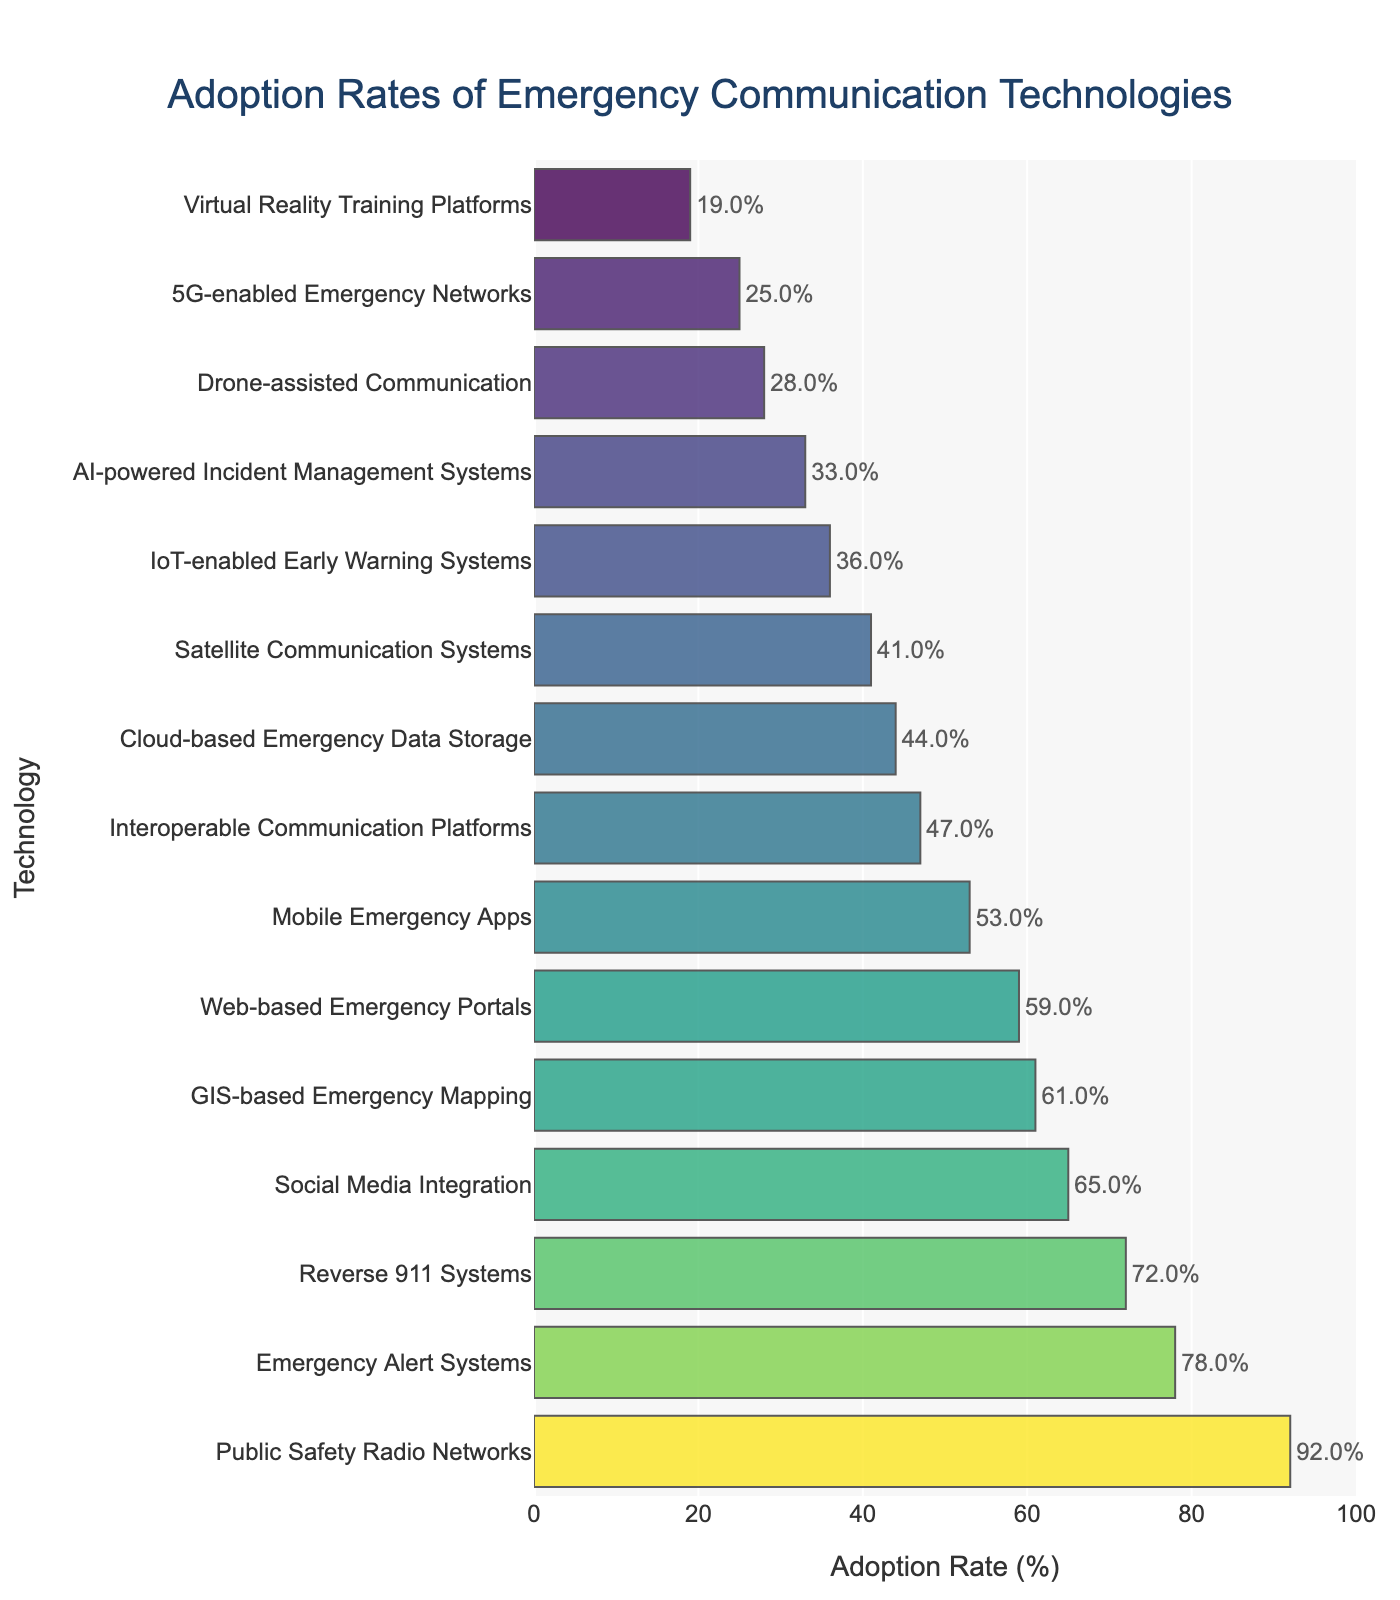Which technology has the highest adoption rate? The adoption rate for each technology is shown by the length of the bar, with the highest bar indicating the highest adoption rate. The Public Safety Radio Networks bar is the longest.
Answer: Public Safety Radio Networks Which technology has the lowest adoption rate? The adoption rate for each technology is shown by the length of the bar, with the shortest bar indicating the lowest adoption rate. The Virtual Reality Training Platforms bar is the shortest.
Answer: Virtual Reality Training Platforms How much higher is the adoption rate of Public Safety Radio Networks compared to Web-based Emergency Portals? The adoption rate for Public Safety Radio Networks is 92%, and for Web-based Emergency Portals, it is 59%. The difference is 92% - 59%.
Answer: 33% What is the combined adoption rate of Social Media Integration, Mobile Emergency Apps, and Satellite Communication Systems? The adoption rates are 65% for Social Media Integration, 53% for Mobile Emergency Apps, and 41% for Satellite Communication Systems. Summing these gives 65% + 53% + 41%.
Answer: 159% Which technologies have an adoption rate higher than 70%? The bars representing technologies with more than a 70% adoption rate are Emergency Alert Systems at 78%, Public Safety Radio Networks at 92%, and Reverse 911 Systems at 72%.
Answer: Emergency Alert Systems, Public Safety Radio Networks, Reverse 911 Systems What is the average adoption rate of the listed technologies? Add all the adoption rates: 78% (Emergency Alert Systems) + 92% (Public Safety Radio Networks) + 65% (Social Media Integration) + 53% (Mobile Emergency Apps) + 41% (Satellite Communication Systems) + 72% (Reverse 911 Systems) + 59% (Web-based Emergency Portals) + 47% (Interoperable Communication Platforms) + 28% (Drone-assisted Communication) + 36% (IoT-enabled Early Warning Systems) + 61% (GIS-based Emergency Mapping) + 33% (AI-powered Incident Management Systems) + 44% (Cloud-based Emergency Data Storage) + 19% (Virtual Reality Training Platforms) + 25% (5G-enabled Emergency Networks), then divide by the number of technologies (15). The total is 753%, so the average is 753/15.
Answer: 50.2% Which technology has an adoption rate closest to the average adoption rate? The calculated average adoption rate is 50.2%. The adoption rate closest to 50.2% belongs to Cloud-based Emergency Data Storage at 44% and Mobile Emergency Apps at 53%. The closest one, 53%, matches Mobile Emergency Apps.
Answer: Mobile Emergency Apps How many technologies have an adoption rate below 40%? Count the bars where the adoption rate is lower than 40%. The bars for Satellite Communication Systems (41%), Reverse 911 Systems (72%), and Web-based Emergency Portals (59%) do not count. The technologies that count are Drone-assisted Communication (28%), IoT-enabled Early Warning Systems (36%), AI-powered Incident Management Systems (33%), Virtual Reality Training Platforms (19%), and 5G-enabled Emergency Networks (25%).
Answer: 5 